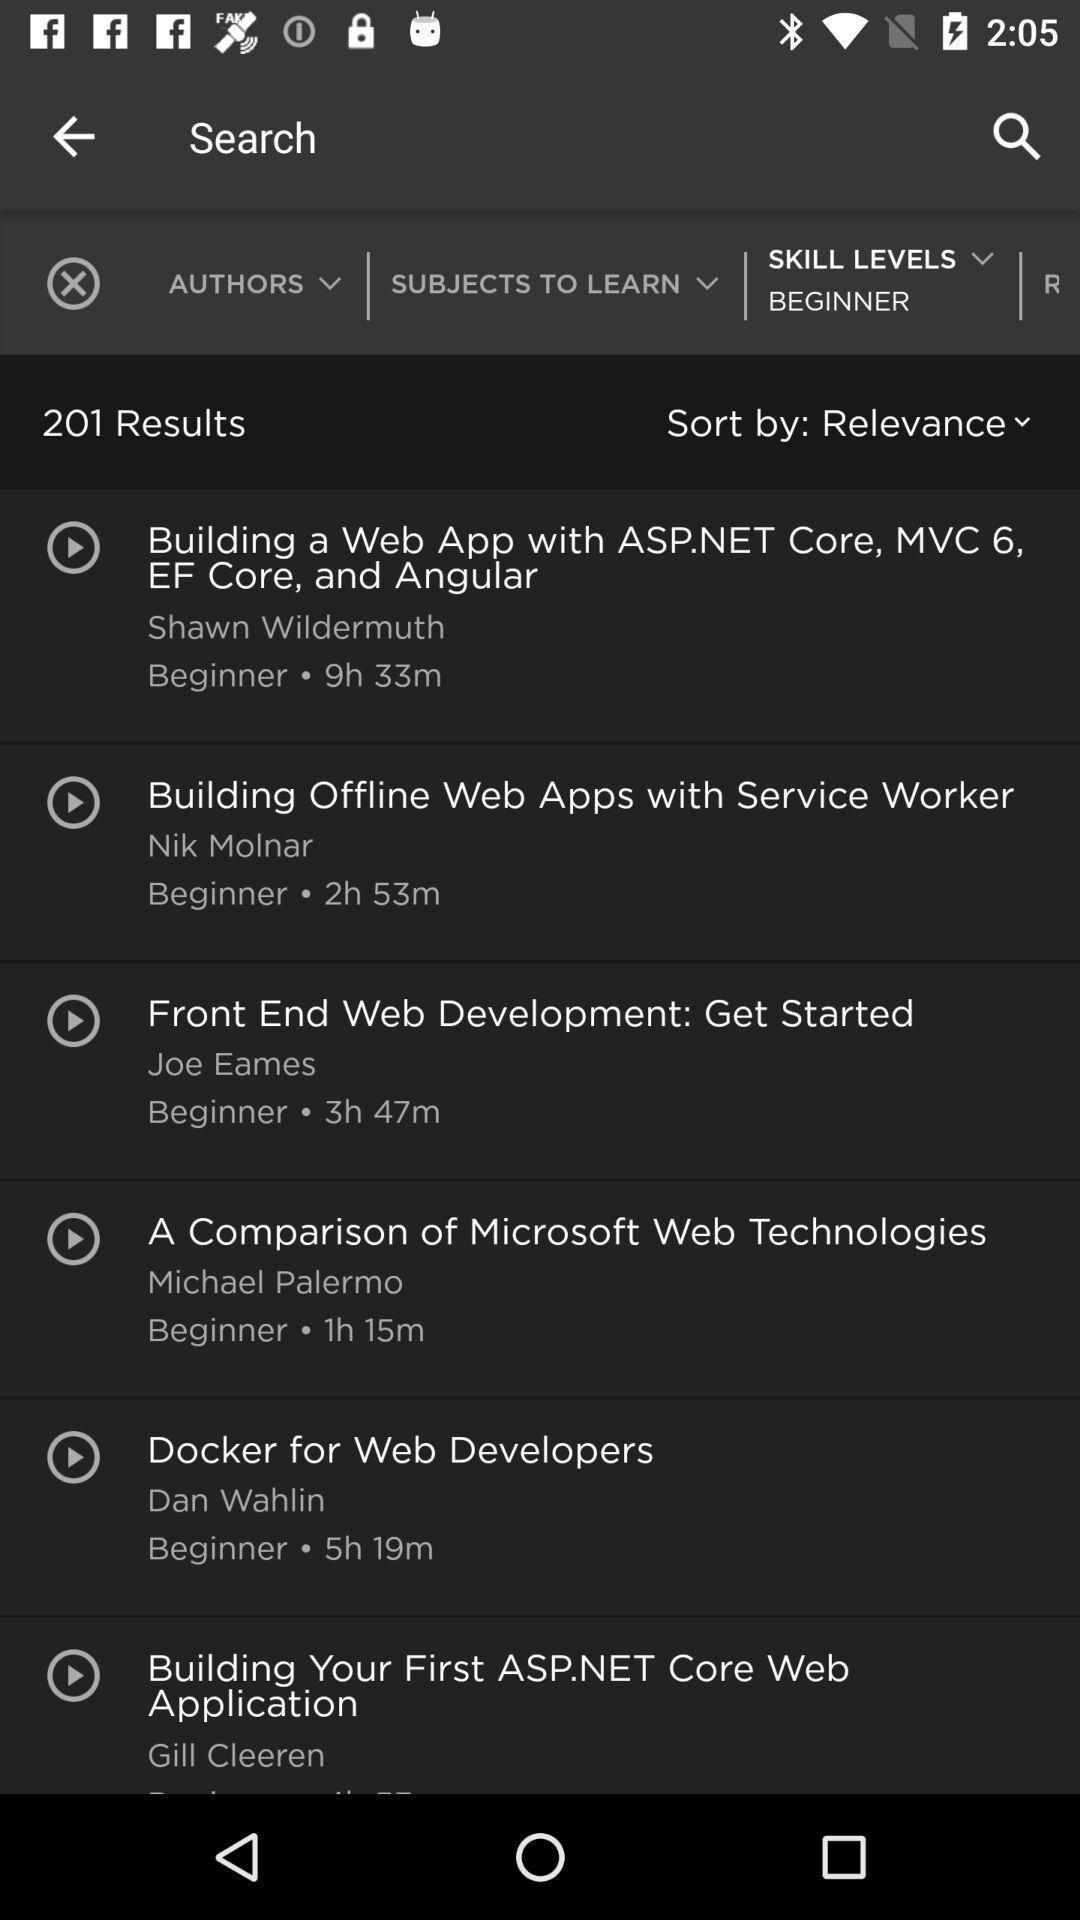Describe the visual elements of this screenshot. Search page. 